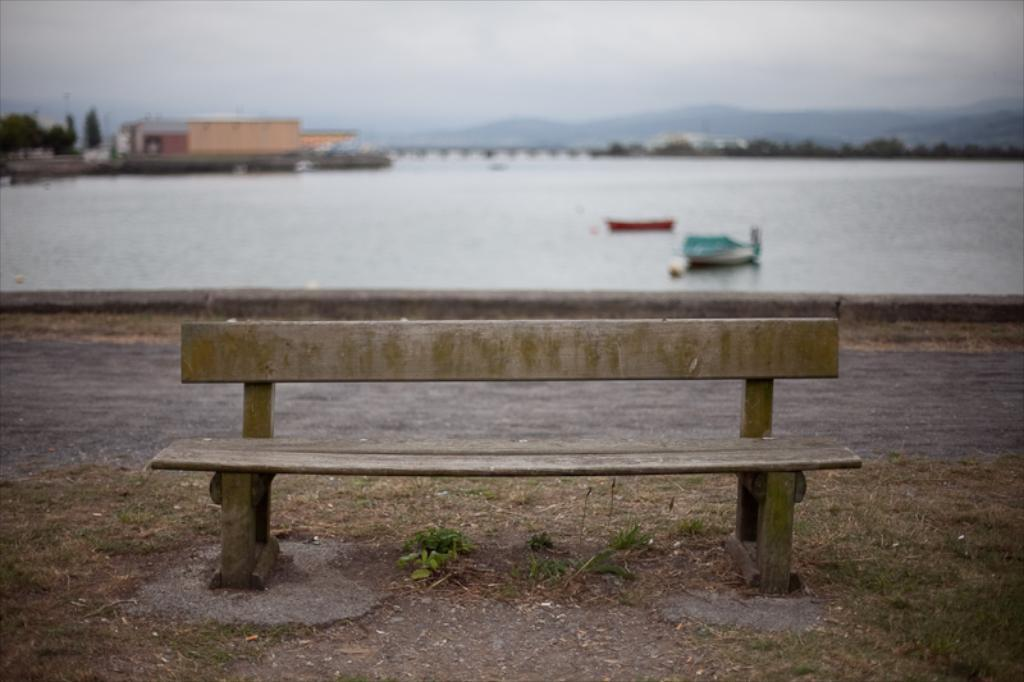What type of natural elements can be seen in the image? There are trees and mountains in the image. What type of man-made structures are present in the image? There are buildings in the image. What type of seating is available in the image? There is a bench in the image. What is visible in the sky in the image? The sky is visible in the image. What type of transportation can be seen on the water surface in the image? There are boats on the water surface in the image. How many passengers are on the bench in the image? There are no passengers mentioned or visible on the bench in the image. What type of wind can be seen blowing in the image? There is no wind or blowing action visible in the image. 